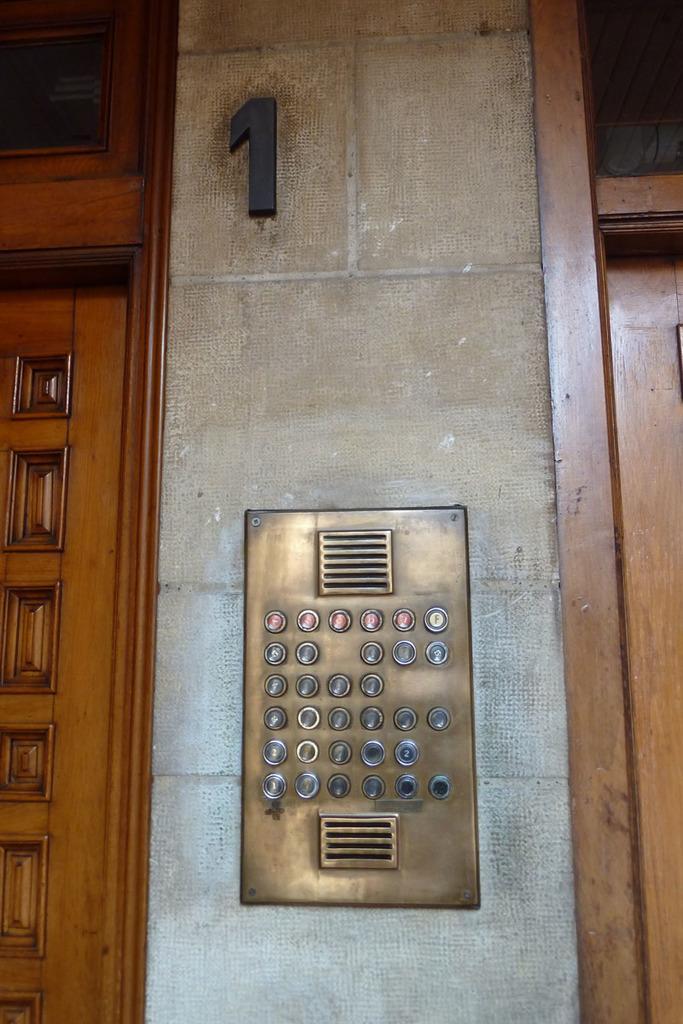Can you describe this image briefly? In this picture I can observe buttons in the middle of the picture. In the top of the picture I can observe a number. On the left side I can observe a design on the wood. 